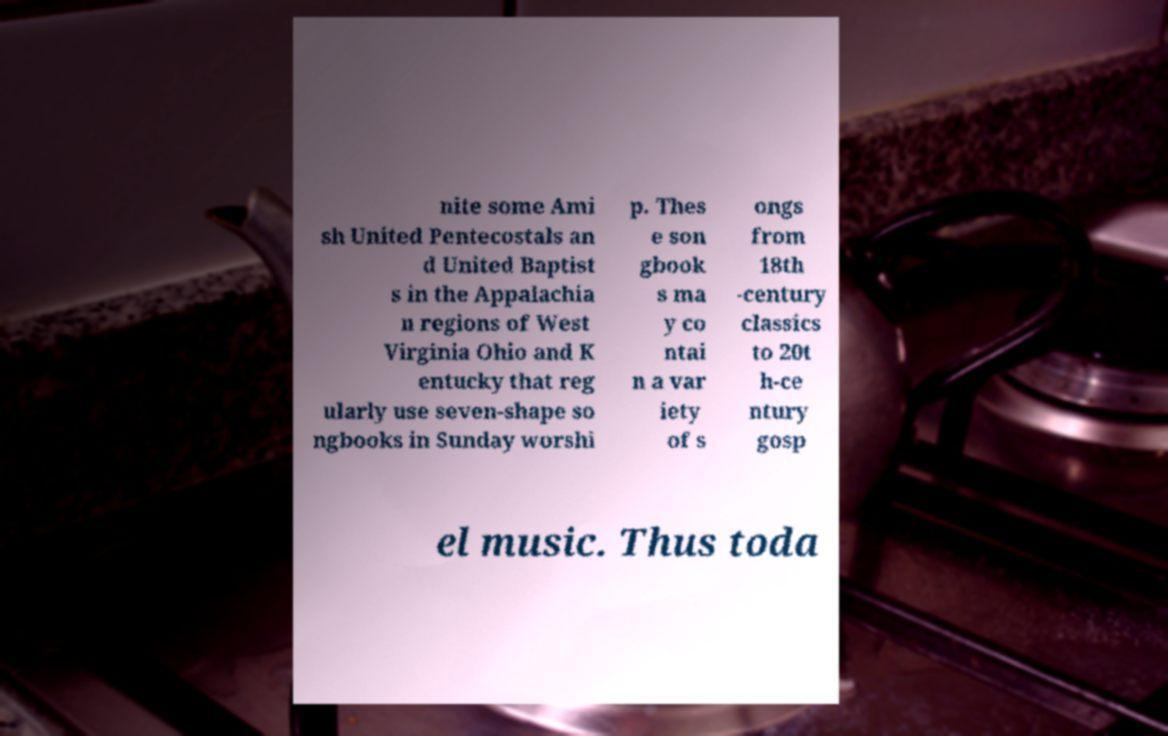Please read and relay the text visible in this image. What does it say? nite some Ami sh United Pentecostals an d United Baptist s in the Appalachia n regions of West Virginia Ohio and K entucky that reg ularly use seven-shape so ngbooks in Sunday worshi p. Thes e son gbook s ma y co ntai n a var iety of s ongs from 18th -century classics to 20t h-ce ntury gosp el music. Thus toda 